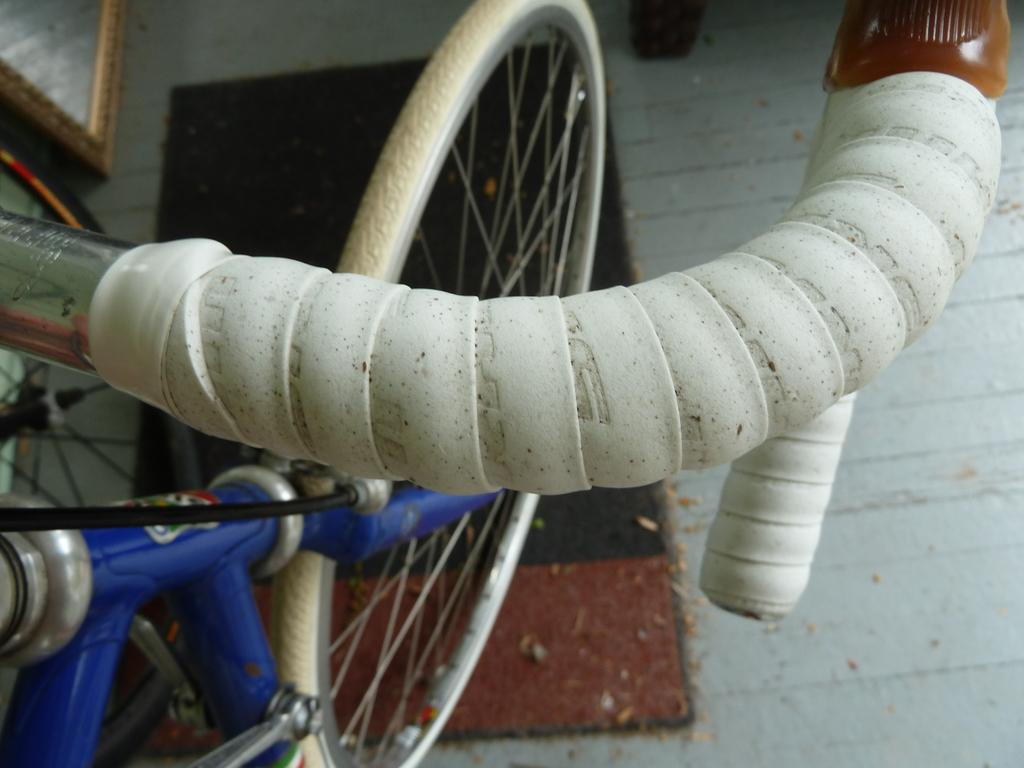Where was the image taken? The image was taken outdoors. What is at the bottom of the image? There is a floor at the bottom of the image. What is placed on the floor? There is a mat on the floor. What can be seen in the middle of the image? A bicycle is parked in the middle of the image. Where is the bicycle located? The bicycle is parked on the floor. What type of thumb can be seen holding the spoon in the image? There is no thumb or spoon present in the image; it features a bicycle parked on a mat. How many dolls are sitting on the bicycle in the image? There are no dolls present in the image; it features a bicycle parked on a mat. 